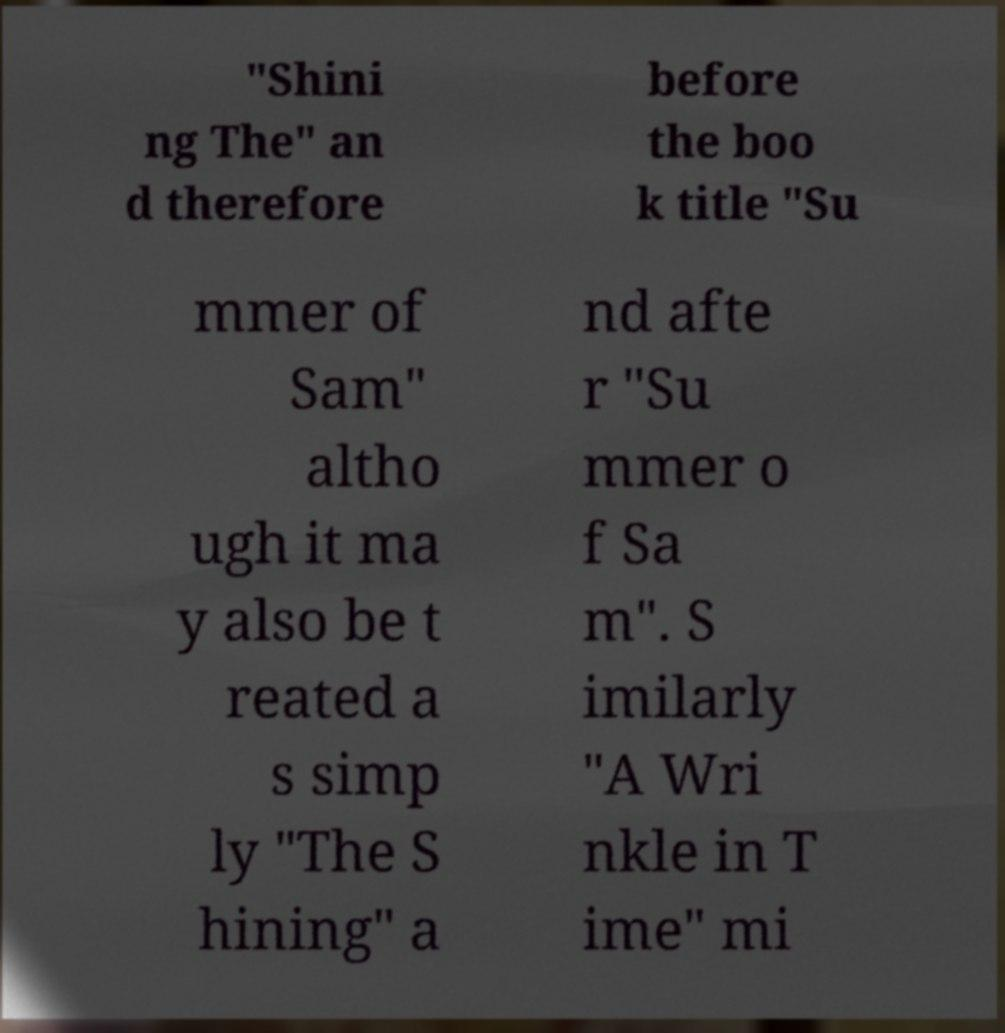Please read and relay the text visible in this image. What does it say? "Shini ng The" an d therefore before the boo k title "Su mmer of Sam" altho ugh it ma y also be t reated a s simp ly "The S hining" a nd afte r "Su mmer o f Sa m". S imilarly "A Wri nkle in T ime" mi 